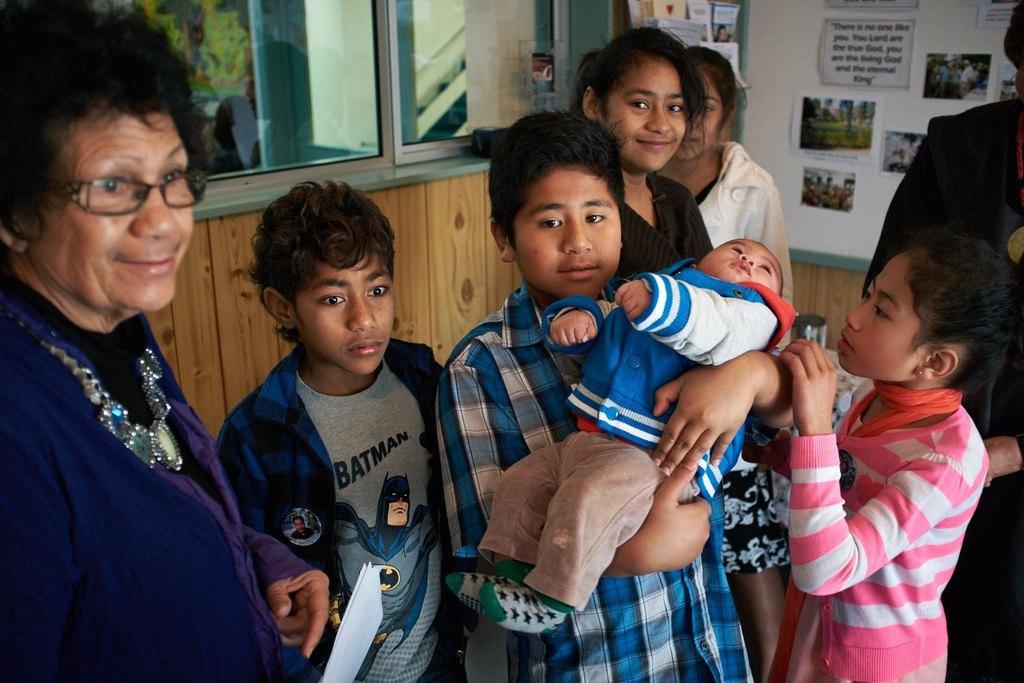Describe this image in one or two sentences. In this image I can see the group of people with different color dresses. In the background I can see the window, photos and many papers are attached to the wall. I can see the trees through the window. 